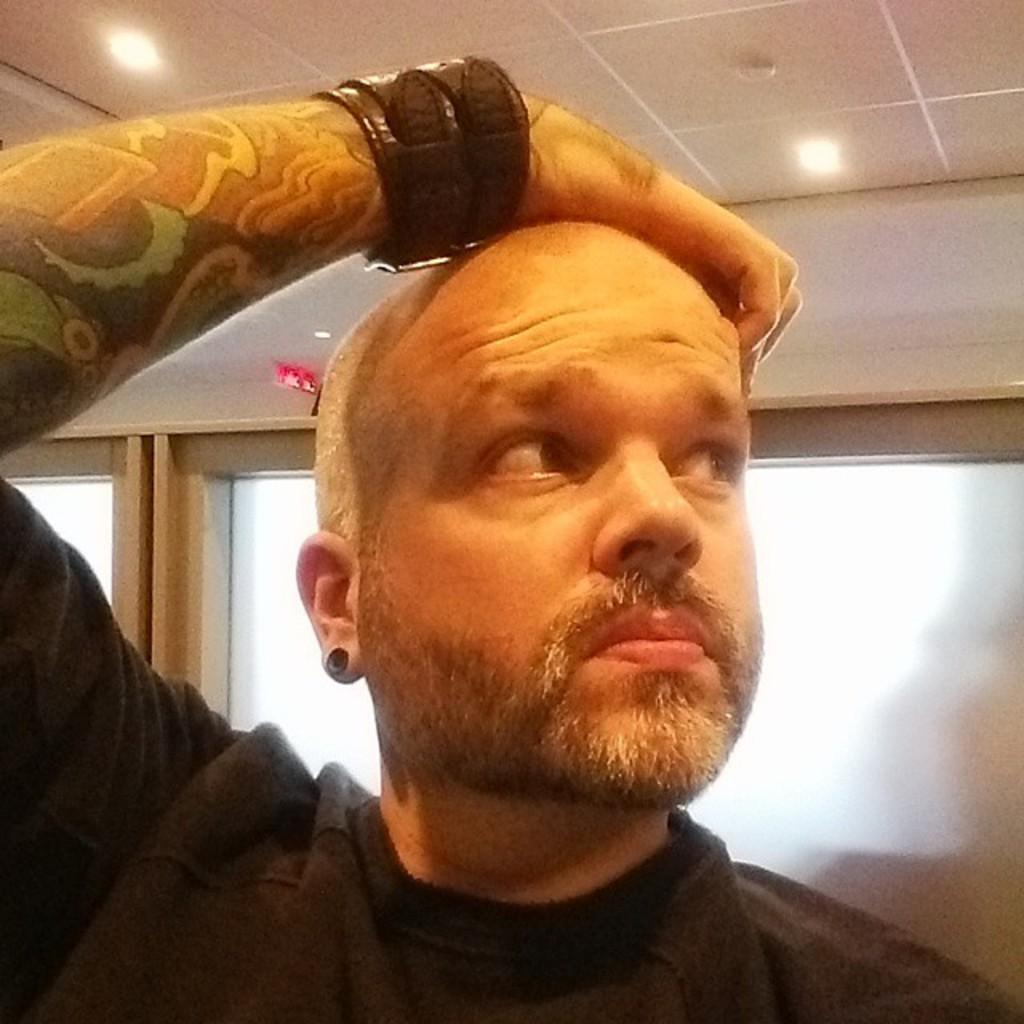What is the main subject of the image? The main subject of the image is a man. What direction is the man looking in? The man is looking towards his right. What is the man wearing on his hand? The man is wearing a band on his hand. What is the man doing with his hand? The man has his hand on his head. How many windows are visible behind the man? There are two windows behind the man. What type of store can be seen in the background of the image? There is no store visible in the background of the image. Does the man have a wing attached to his back in the image? No, the man does not have a wing attached to his back in the image. 